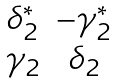<formula> <loc_0><loc_0><loc_500><loc_500>\begin{matrix} \delta _ { 2 } ^ { * } & - \gamma _ { 2 } ^ { * } \\ \gamma _ { 2 } & \delta _ { 2 } \end{matrix}</formula> 